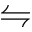<formula> <loc_0><loc_0><loc_500><loc_500>\leftrightharpoons</formula> 